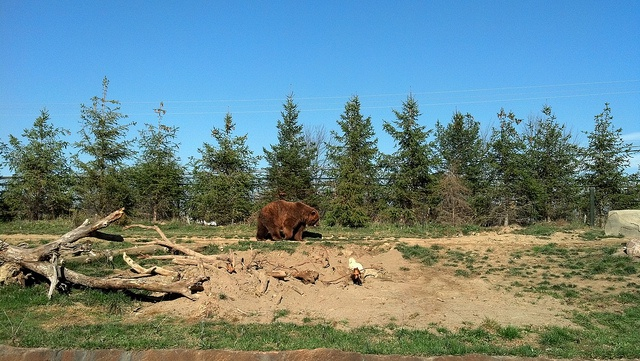Describe the objects in this image and their specific colors. I can see bear in gray, maroon, black, and brown tones and bird in gray, black, maroon, and tan tones in this image. 